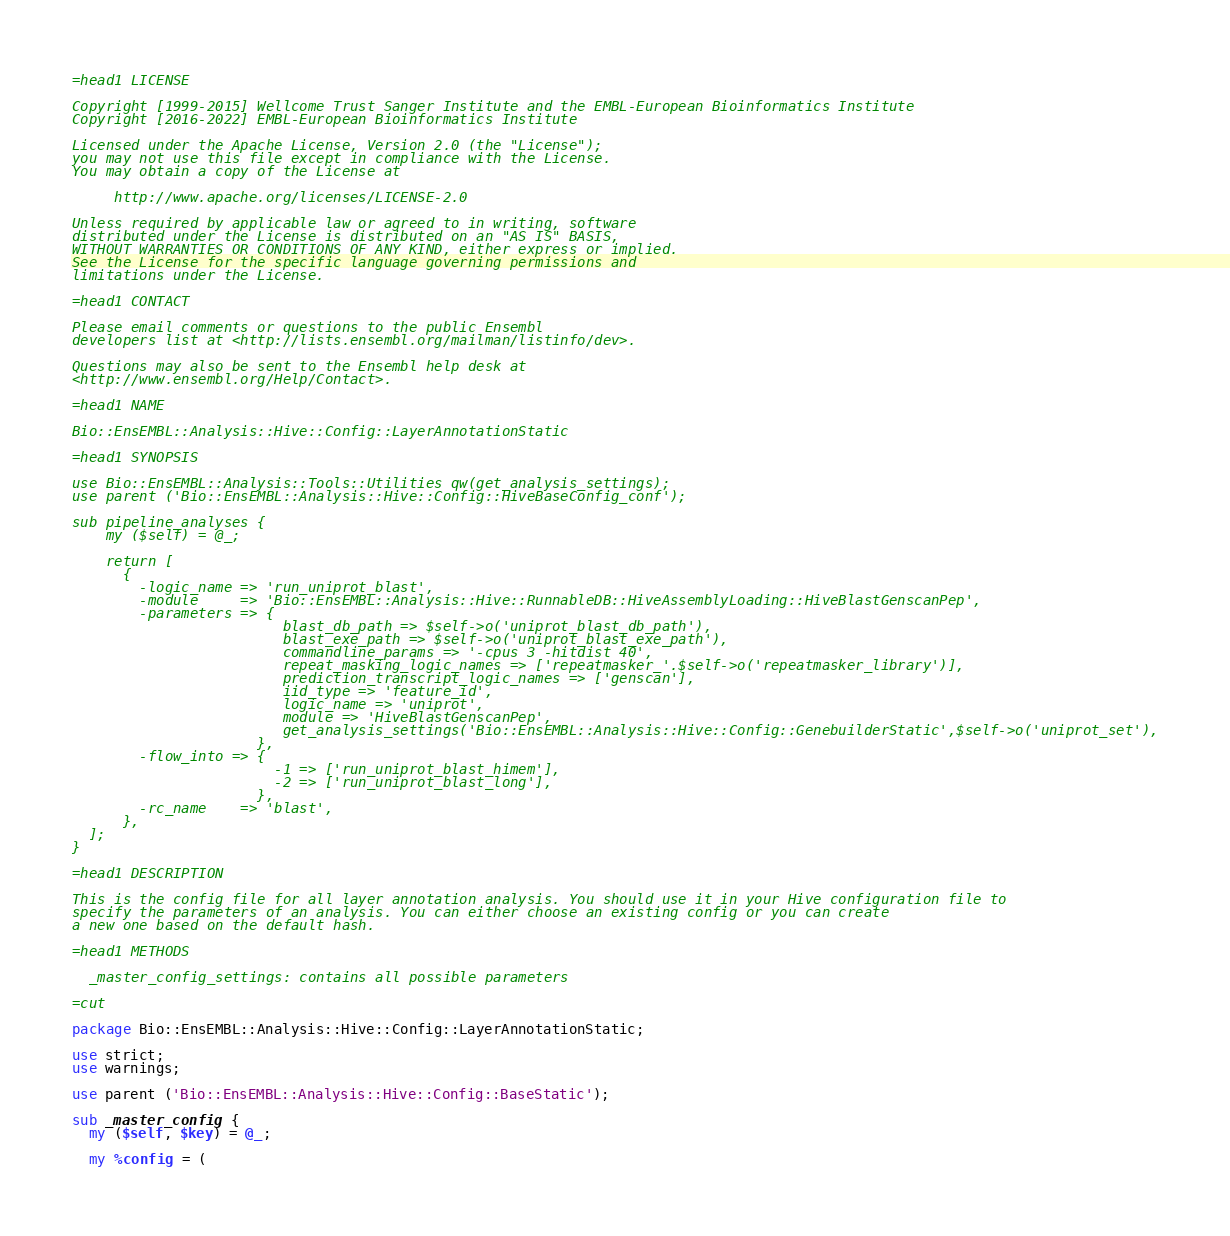Convert code to text. <code><loc_0><loc_0><loc_500><loc_500><_Perl_>=head1 LICENSE

Copyright [1999-2015] Wellcome Trust Sanger Institute and the EMBL-European Bioinformatics Institute
Copyright [2016-2022] EMBL-European Bioinformatics Institute

Licensed under the Apache License, Version 2.0 (the "License");
you may not use this file except in compliance with the License.
You may obtain a copy of the License at

     http://www.apache.org/licenses/LICENSE-2.0

Unless required by applicable law or agreed to in writing, software
distributed under the License is distributed on an "AS IS" BASIS,
WITHOUT WARRANTIES OR CONDITIONS OF ANY KIND, either express or implied.
See the License for the specific language governing permissions and
limitations under the License.

=head1 CONTACT

Please email comments or questions to the public Ensembl
developers list at <http://lists.ensembl.org/mailman/listinfo/dev>.

Questions may also be sent to the Ensembl help desk at
<http://www.ensembl.org/Help/Contact>.

=head1 NAME

Bio::EnsEMBL::Analysis::Hive::Config::LayerAnnotationStatic

=head1 SYNOPSIS

use Bio::EnsEMBL::Analysis::Tools::Utilities qw(get_analysis_settings);
use parent ('Bio::EnsEMBL::Analysis::Hive::Config::HiveBaseConfig_conf');

sub pipeline_analyses {
    my ($self) = @_;

    return [
      {
        -logic_name => 'run_uniprot_blast',
        -module     => 'Bio::EnsEMBL::Analysis::Hive::RunnableDB::HiveAssemblyLoading::HiveBlastGenscanPep',
        -parameters => {
                         blast_db_path => $self->o('uniprot_blast_db_path'),
                         blast_exe_path => $self->o('uniprot_blast_exe_path'),
                         commandline_params => '-cpus 3 -hitdist 40',
                         repeat_masking_logic_names => ['repeatmasker_'.$self->o('repeatmasker_library')],
                         prediction_transcript_logic_names => ['genscan'],
                         iid_type => 'feature_id',
                         logic_name => 'uniprot',
                         module => 'HiveBlastGenscanPep',
                         get_analysis_settings('Bio::EnsEMBL::Analysis::Hive::Config::GenebuilderStatic',$self->o('uniprot_set'),
                      },
        -flow_into => {
                        -1 => ['run_uniprot_blast_himem'],
                        -2 => ['run_uniprot_blast_long'],
                      },
        -rc_name    => 'blast',
      },
  ];
}

=head1 DESCRIPTION

This is the config file for all layer annotation analysis. You should use it in your Hive configuration file to
specify the parameters of an analysis. You can either choose an existing config or you can create
a new one based on the default hash.

=head1 METHODS

  _master_config_settings: contains all possible parameters

=cut

package Bio::EnsEMBL::Analysis::Hive::Config::LayerAnnotationStatic;

use strict;
use warnings;

use parent ('Bio::EnsEMBL::Analysis::Hive::Config::BaseStatic');

sub _master_config {
  my ($self, $key) = @_;

  my %config = (</code> 